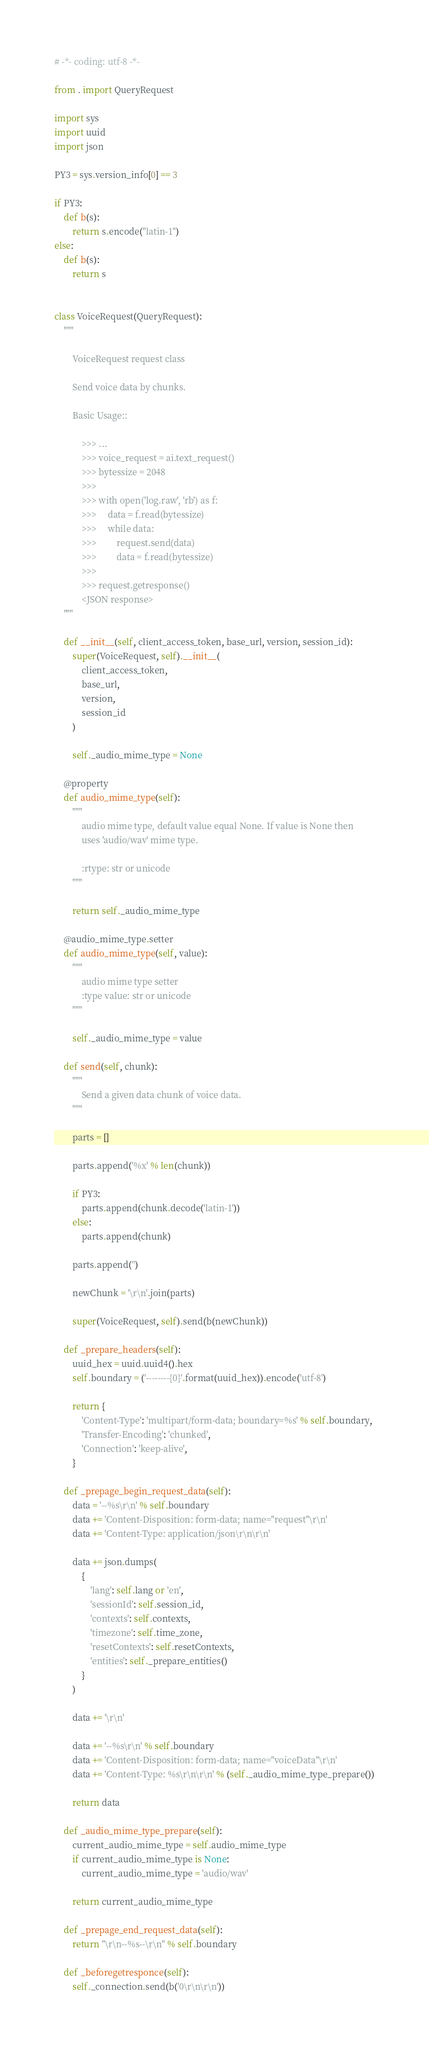<code> <loc_0><loc_0><loc_500><loc_500><_Python_># -*- coding: utf-8 -*-

from . import QueryRequest

import sys
import uuid
import json

PY3 = sys.version_info[0] == 3

if PY3:
    def b(s):
        return s.encode("latin-1")
else:
    def b(s):
        return s


class VoiceRequest(QueryRequest):
    """

        VoiceRequest request class

        Send voice data by chunks.

        Basic Usage::

            >>> ...
            >>> voice_request = ai.text_request()
            >>> bytessize = 2048
            >>>
            >>> with open('log.raw', 'rb') as f:
            >>>     data = f.read(bytessize)
            >>>     while data:
            >>>         request.send(data)
            >>>         data = f.read(bytessize)
            >>>
            >>> request.getresponse()
            <JSON response>
    """

    def __init__(self, client_access_token, base_url, version, session_id):
        super(VoiceRequest, self).__init__(
            client_access_token,
            base_url,
            version,
            session_id
        )

        self._audio_mime_type = None

    @property
    def audio_mime_type(self):
        """
            audio mime type, default value equal None. If value is None then
            uses 'audio/wav' mime type.

            :rtype: str or unicode
        """

        return self._audio_mime_type

    @audio_mime_type.setter
    def audio_mime_type(self, value):
        """
            audio mime type setter
            :type value: str or unicode
        """

        self._audio_mime_type = value

    def send(self, chunk):
        """
            Send a given data chunk of voice data.
        """

        parts = []

        parts.append('%x' % len(chunk))

        if PY3:
            parts.append(chunk.decode('latin-1'))
        else:
            parts.append(chunk)

        parts.append('')

        newChunk = '\r\n'.join(parts)

        super(VoiceRequest, self).send(b(newChunk))

    def _prepare_headers(self):
        uuid_hex = uuid.uuid4().hex
        self.boundary = ('--------{0}'.format(uuid_hex)).encode('utf-8')

        return {
            'Content-Type': 'multipart/form-data; boundary=%s' % self.boundary,
            'Transfer-Encoding': 'chunked',
            'Connection': 'keep-alive',
        }

    def _prepage_begin_request_data(self):
        data = '--%s\r\n' % self.boundary
        data += 'Content-Disposition: form-data; name="request"\r\n'
        data += 'Content-Type: application/json\r\n\r\n'

        data += json.dumps(
            {
                'lang': self.lang or 'en',
                'sessionId': self.session_id,
                'contexts': self.contexts,
                'timezone': self.time_zone,
                'resetContexts': self.resetContexts,
                'entities': self._prepare_entities()
            }
        )

        data += '\r\n'

        data += '--%s\r\n' % self.boundary
        data += 'Content-Disposition: form-data; name="voiceData"\r\n'
        data += 'Content-Type: %s\r\n\r\n' % (self._audio_mime_type_prepare())

        return data

    def _audio_mime_type_prepare(self):
        current_audio_mime_type = self.audio_mime_type
        if current_audio_mime_type is None:
            current_audio_mime_type = 'audio/wav'

        return current_audio_mime_type

    def _prepage_end_request_data(self):
        return "\r\n--%s--\r\n" % self.boundary

    def _beforegetresponce(self):
        self._connection.send(b('0\r\n\r\n'))
</code> 